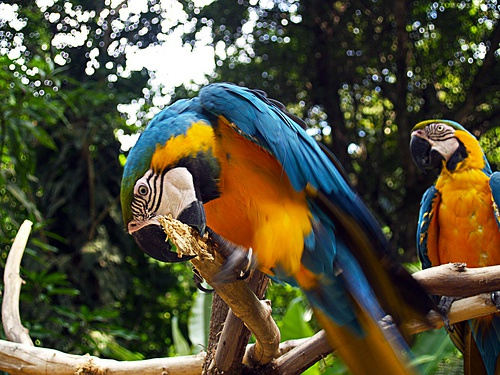Describe the objects in this image and their specific colors. I can see bird in black, brown, maroon, and orange tones and bird in black, brown, maroon, and orange tones in this image. 